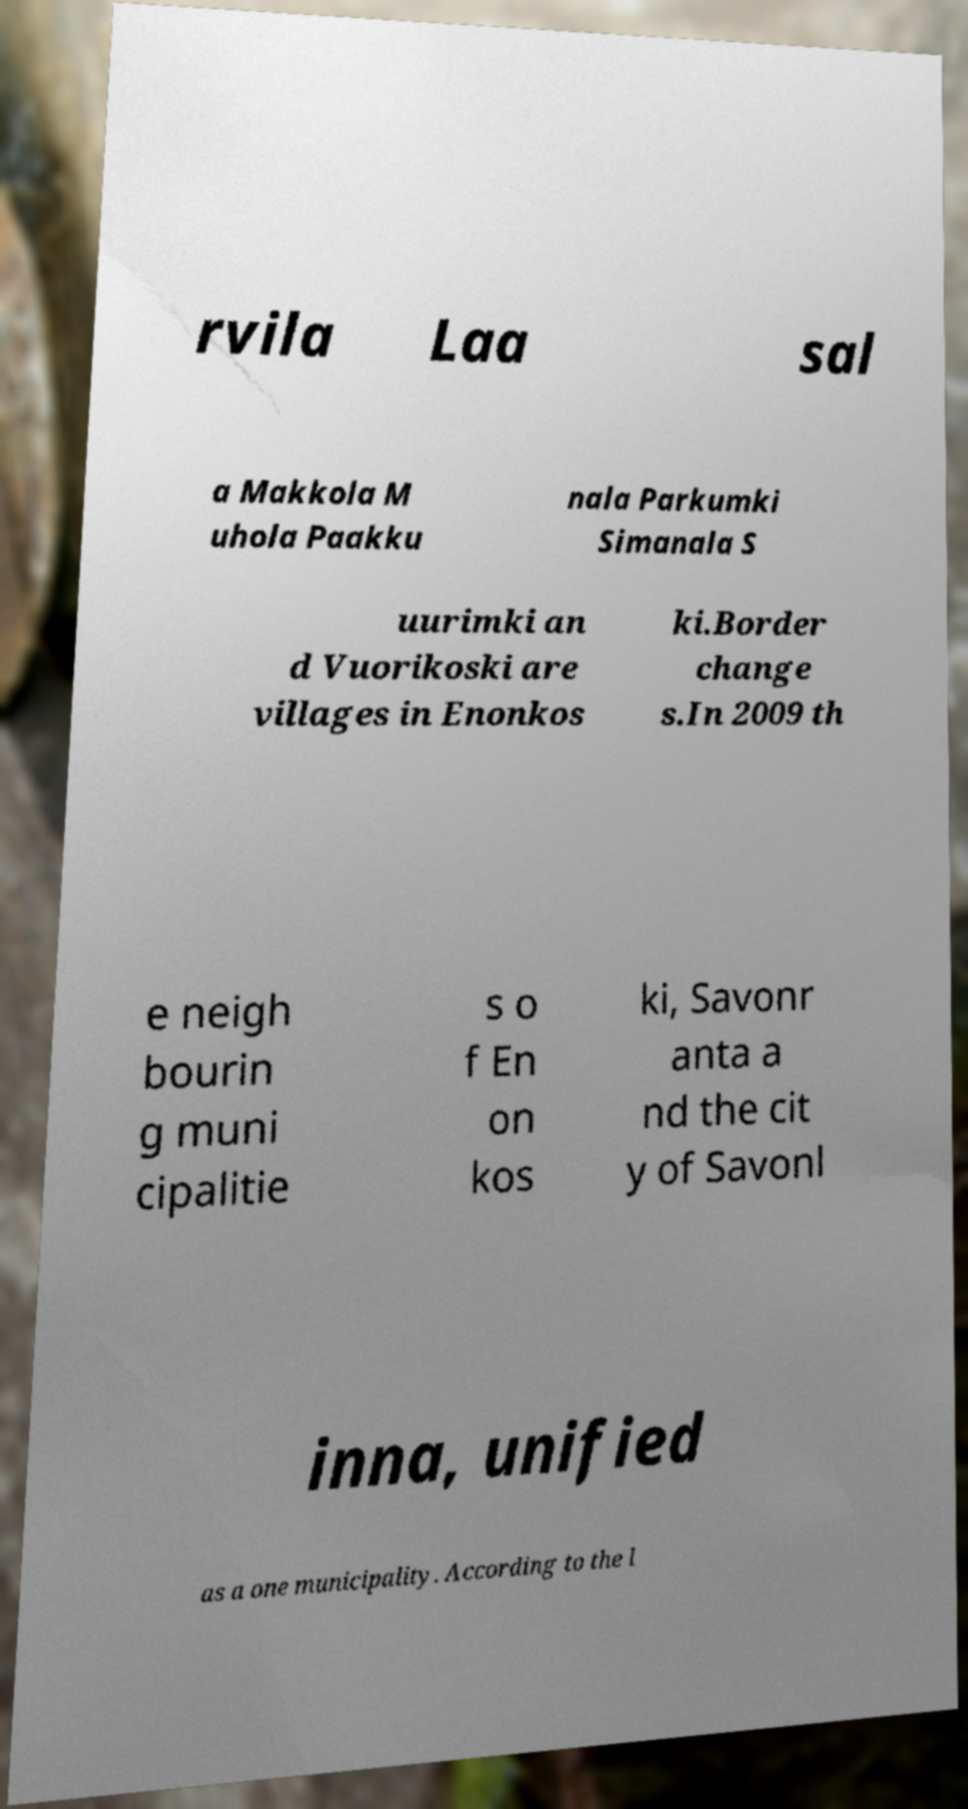There's text embedded in this image that I need extracted. Can you transcribe it verbatim? rvila Laa sal a Makkola M uhola Paakku nala Parkumki Simanala S uurimki an d Vuorikoski are villages in Enonkos ki.Border change s.In 2009 th e neigh bourin g muni cipalitie s o f En on kos ki, Savonr anta a nd the cit y of Savonl inna, unified as a one municipality. According to the l 